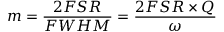<formula> <loc_0><loc_0><loc_500><loc_500>m = \frac { 2 F S R } { F W H M } = \frac { 2 F S R \times Q } { \omega }</formula> 